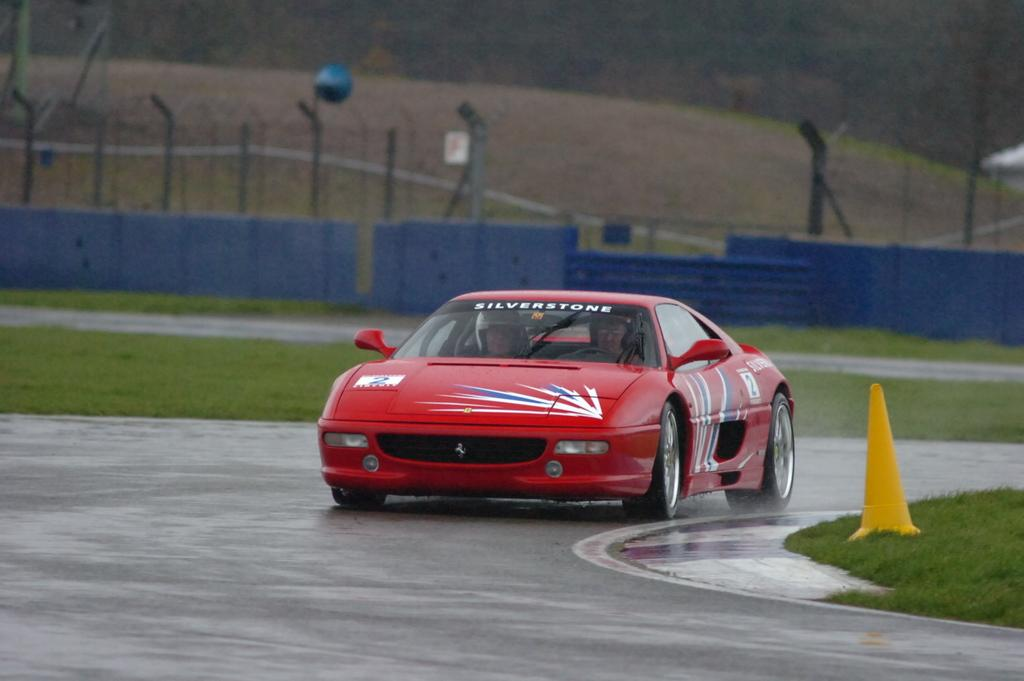What is on the road in the image? There is a car on the road in the image. What object can be seen near the road? There is a traffic cone in the image. What type of vegetation is present in the image? Grass is present in the image. What type of barrier is visible in the image? There is a fence in the image. What vertical structures can be seen in the image? Poles are visible in the image. How would you describe the background of the image? The background of the image is blurred. Can you see a group of people flying a kite in the image? There is no group of people flying a kite in the image. Is there any water visible in the image? There is no water present in the image. 